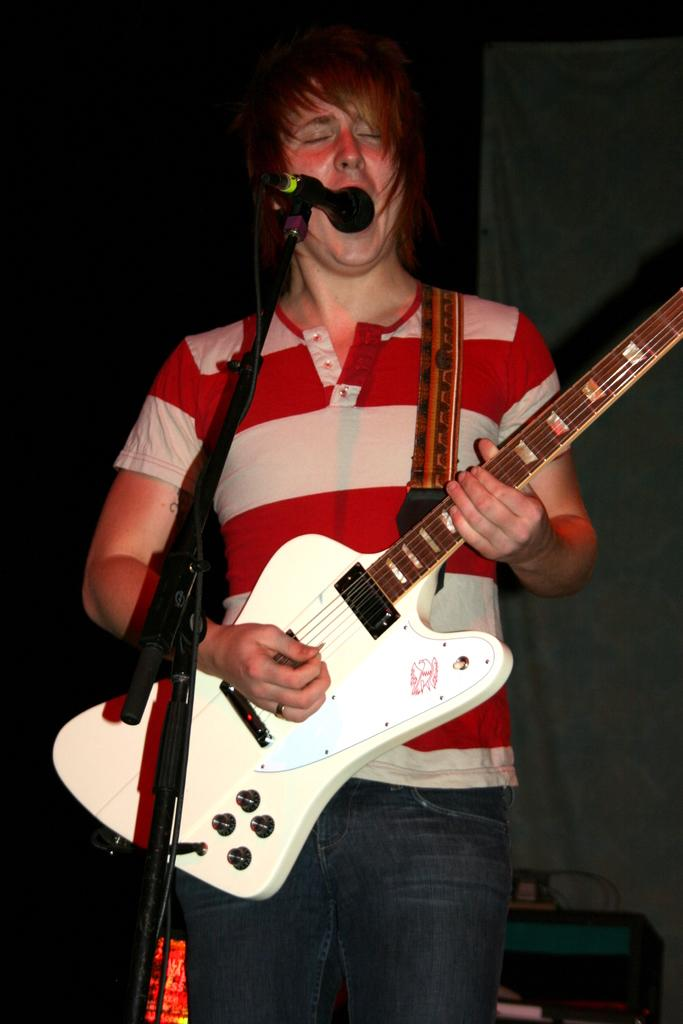What is the person in the image doing? The person is playing the guitar and singing through the microphone. What instrument is the person holding? The person is holding a guitar. What is the purpose of the microphone in front of the person? The microphone is used for amplifying the person's voice while singing. How many dimes are visible on the guitar in the image? There are no dimes visible on the guitar in the image. What type of grain is present in the image? There is no grain present in the image. 